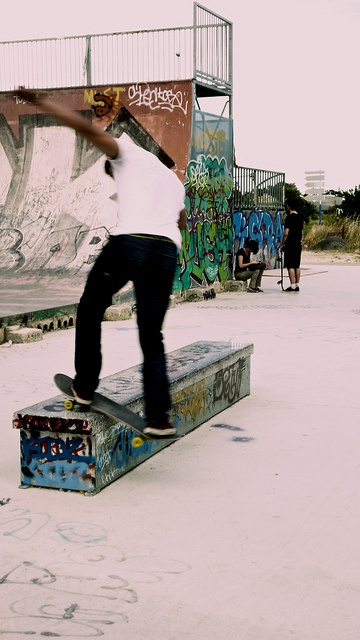Describe the objects in this image and their specific colors. I can see people in lightgray, black, gray, and maroon tones, bench in lightgray, gray, black, darkgray, and darkgreen tones, people in lightgray, black, gray, and maroon tones, skateboard in lightgray, black, gray, darkgreen, and purple tones, and people in lightgray, black, and gray tones in this image. 